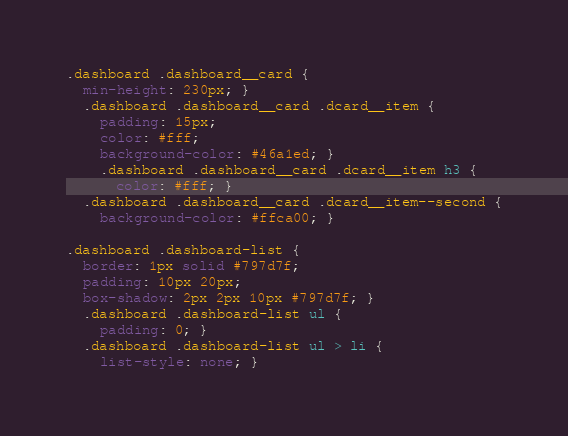Convert code to text. <code><loc_0><loc_0><loc_500><loc_500><_CSS_>.dashboard .dashboard__card {
  min-height: 230px; }
  .dashboard .dashboard__card .dcard__item {
    padding: 15px;
    color: #fff;
    background-color: #46a1ed; }
    .dashboard .dashboard__card .dcard__item h3 {
      color: #fff; }
  .dashboard .dashboard__card .dcard__item--second {
    background-color: #ffca00; }

.dashboard .dashboard-list {
  border: 1px solid #797d7f;
  padding: 10px 20px;
  box-shadow: 2px 2px 10px #797d7f; }
  .dashboard .dashboard-list ul {
    padding: 0; }
  .dashboard .dashboard-list ul > li {
    list-style: none; }
</code> 